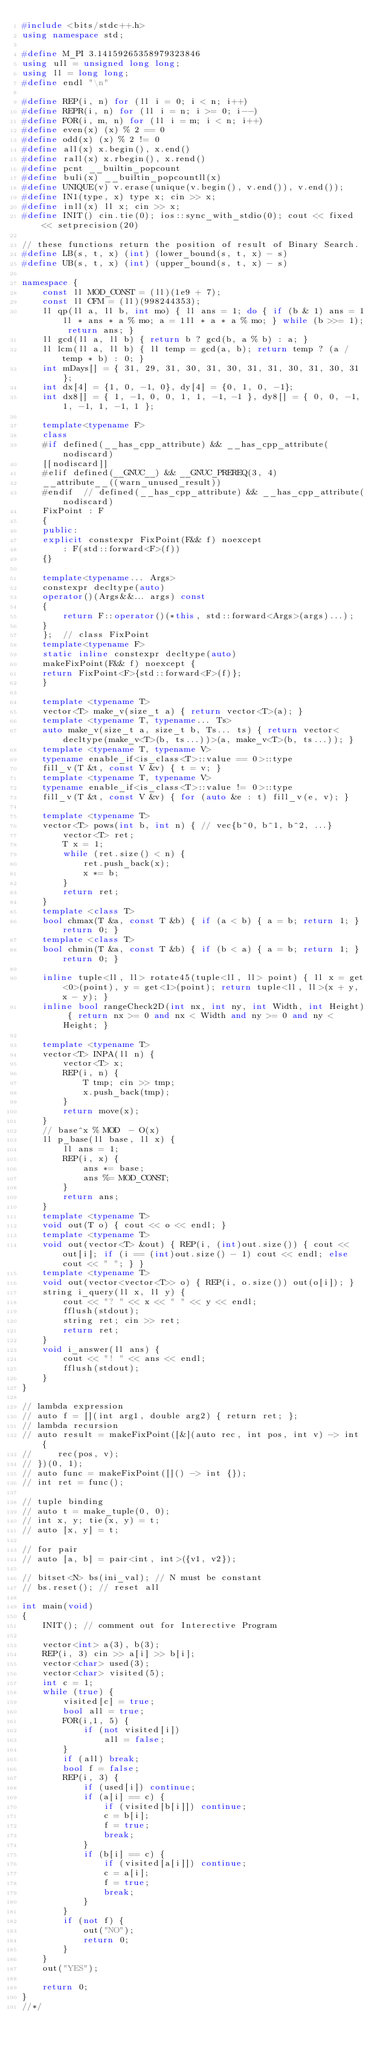<code> <loc_0><loc_0><loc_500><loc_500><_C++_>#include <bits/stdc++.h>
using namespace std;

#define M_PI 3.14159265358979323846
using ull = unsigned long long;
using ll = long long;
#define endl "\n"

#define REP(i, n) for (ll i = 0; i < n; i++)
#define REPR(i, n) for (ll i = n; i >= 0; i--)
#define FOR(i, m, n) for (ll i = m; i < n; i++)
#define even(x) (x) % 2 == 0
#define odd(x) (x) % 2 != 0
#define all(x) x.begin(), x.end()
#define rall(x) x.rbegin(), x.rend()
#define pcnt __builtin_popcount
#define buli(x) __builtin_popcountll(x)
#define UNIQUE(v) v.erase(unique(v.begin(), v.end()), v.end());
#define IN1(type, x) type x; cin >> x;
#define inll(x) ll x; cin >> x;
#define INIT() cin.tie(0); ios::sync_with_stdio(0); cout << fixed << setprecision(20)

// these functions return the position of result of Binary Search.
#define LB(s, t, x) (int) (lower_bound(s, t, x) - s)
#define UB(s, t, x) (int) (upper_bound(s, t, x) - s)

namespace {
    const ll MOD_CONST = (ll)(1e9 + 7);
    const ll CFM = (ll)(998244353);
    ll qp(ll a, ll b, int mo) { ll ans = 1; do { if (b & 1) ans = 1ll * ans * a % mo; a = 1ll * a * a % mo; } while (b >>= 1); return ans; }
    ll gcd(ll a, ll b) { return b ? gcd(b, a % b) : a; }
    ll lcm(ll a, ll b) { ll temp = gcd(a, b); return temp ? (a / temp * b) : 0; }
    int mDays[] = { 31, 29, 31, 30, 31, 30, 31, 31, 30, 31, 30, 31 };
    int dx[4] = {1, 0, -1, 0}, dy[4] = {0, 1, 0, -1};
    int dx8[] = { 1, -1, 0, 0, 1, 1, -1, -1 }, dy8[] = { 0, 0, -1, 1, -1, 1, -1, 1 };

    template<typename F>
    class
    #if defined(__has_cpp_attribute) && __has_cpp_attribute(nodiscard)
    [[nodiscard]]
    #elif defined(__GNUC__) && __GNUC_PREREQ(3, 4)
    __attribute__((warn_unused_result))
    #endif  // defined(__has_cpp_attribute) && __has_cpp_attribute(nodiscard)
    FixPoint : F
    {
    public:
    explicit constexpr FixPoint(F&& f) noexcept
        : F(std::forward<F>(f))
    {}

    template<typename... Args>
    constexpr decltype(auto)
    operator()(Args&&... args) const
    {
        return F::operator()(*this, std::forward<Args>(args)...);
    }
    };  // class FixPoint
    template<typename F>
    static inline constexpr decltype(auto)
    makeFixPoint(F&& f) noexcept {
    return FixPoint<F>{std::forward<F>(f)};
    }

    template <typename T>
    vector<T> make_v(size_t a) { return vector<T>(a); }
    template <typename T, typename... Ts>
    auto make_v(size_t a, size_t b, Ts... ts) { return vector<decltype(make_v<T>(b, ts...))>(a, make_v<T>(b, ts...)); }
    template <typename T, typename V>
    typename enable_if<is_class<T>::value == 0>::type
    fill_v(T &t, const V &v) { t = v; }
    template <typename T, typename V>
    typename enable_if<is_class<T>::value != 0>::type
    fill_v(T &t, const V &v) { for (auto &e : t) fill_v(e, v); }

    template <typename T>
    vector<T> pows(int b, int n) { // vec{b^0, b^1, b^2, ...}
        vector<T> ret;
        T x = 1;
        while (ret.size() < n) {
            ret.push_back(x);
            x *= b;
        }
        return ret;
    }
    template <class T>
    bool chmax(T &a, const T &b) { if (a < b) { a = b; return 1; } return 0; }
    template <class T>
    bool chmin(T &a, const T &b) { if (b < a) { a = b; return 1; } return 0; }

    inline tuple<ll, ll> rotate45(tuple<ll, ll> point) { ll x = get<0>(point), y = get<1>(point); return tuple<ll, ll>(x + y, x - y); }
    inline bool rangeCheck2D(int nx, int ny, int Width, int Height) { return nx >= 0 and nx < Width and ny >= 0 and ny < Height; }

    template <typename T>
    vector<T> INPA(ll n) {
        vector<T> x;
        REP(i, n) {
            T tmp; cin >> tmp;
            x.push_back(tmp);
        }
        return move(x);
    }
    // base^x % MOD  - O(x)
    ll p_base(ll base, ll x) {
        ll ans = 1;
        REP(i, x) {
            ans *= base;
            ans %= MOD_CONST;
        }
        return ans;
    }
    template <typename T>
    void out(T o) { cout << o << endl; }
    template <typename T>
    void out(vector<T> &out) { REP(i, (int)out.size()) { cout << out[i]; if (i == (int)out.size() - 1) cout << endl; else cout << " "; } }
    template <typename T>
    void out(vector<vector<T>> o) { REP(i, o.size()) out(o[i]); }
    string i_query(ll x, ll y) {
        cout << "? " << x << " " << y << endl;
        fflush(stdout);
        string ret; cin >> ret;
        return ret;
    }
    void i_answer(ll ans) {
        cout << "! " << ans << endl;
        fflush(stdout);
    }
}

// lambda expression
// auto f = [](int arg1, double arg2) { return ret; };
// lambda recursion
// auto result = makeFixPoint([&](auto rec, int pos, int v) -> int {
//	   rec(pos, v);
// })(0, 1);
// auto func = makeFixPoint([]() -> int {});
// int ret = func();

// tuple binding
// auto t = make_tuple(0, 0);
// int x, y; tie(x, y) = t;
// auto [x, y] = t;

// for pair
// auto [a, b] = pair<int, int>({v1, v2});

// bitset<N> bs(ini_val); // N must be constant
// bs.reset(); // reset all

int main(void)
{
    INIT(); // comment out for Interective Program

    vector<int> a(3), b(3);
    REP(i, 3) cin >> a[i] >> b[i];
    vector<char> used(3);
    vector<char> visited(5);
    int c = 1;
    while (true) {
        visited[c] = true;
        bool all = true;
        FOR(i,1, 5) {
            if (not visited[i])
                all = false;
        }
        if (all) break;
        bool f = false;
        REP(i, 3) {
            if (used[i]) continue;
            if (a[i] == c) {
                if (visited[b[i]]) continue;
                c = b[i];
                f = true;
                break;
            }
            if (b[i] == c) {
                if (visited[a[i]]) continue;
                c = a[i];
                f = true;
                break;
            }
        }
        if (not f) {
            out("NO");
            return 0;
        }
    }
    out("YES");

    return 0;
}
//*/</code> 